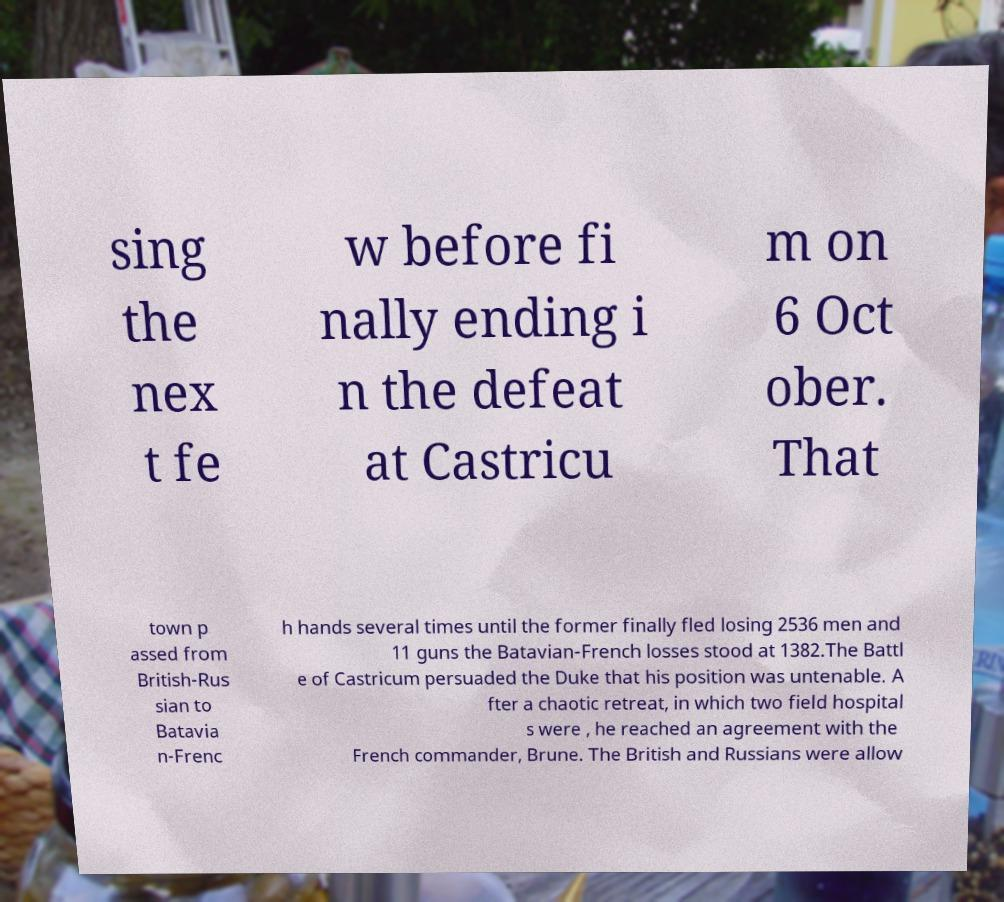What messages or text are displayed in this image? I need them in a readable, typed format. sing the nex t fe w before fi nally ending i n the defeat at Castricu m on 6 Oct ober. That town p assed from British-Rus sian to Batavia n-Frenc h hands several times until the former finally fled losing 2536 men and 11 guns the Batavian-French losses stood at 1382.The Battl e of Castricum persuaded the Duke that his position was untenable. A fter a chaotic retreat, in which two field hospital s were , he reached an agreement with the French commander, Brune. The British and Russians were allow 